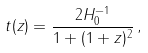Convert formula to latex. <formula><loc_0><loc_0><loc_500><loc_500>t ( z ) = \frac { 2 H _ { 0 } ^ { - 1 } } { 1 + ( 1 + z ) ^ { 2 } } \, ,</formula> 